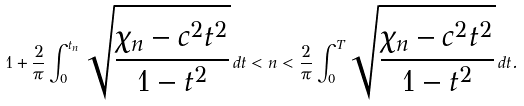<formula> <loc_0><loc_0><loc_500><loc_500>1 + \frac { 2 } { \pi } \int _ { 0 } ^ { t _ { n } } \sqrt { \frac { \chi _ { n } - c ^ { 2 } t ^ { 2 } } { 1 - t ^ { 2 } } } \, d t < n < \frac { 2 } { \pi } \int _ { 0 } ^ { T } \sqrt { \frac { \chi _ { n } - c ^ { 2 } t ^ { 2 } } { 1 - t ^ { 2 } } } \, d t .</formula> 